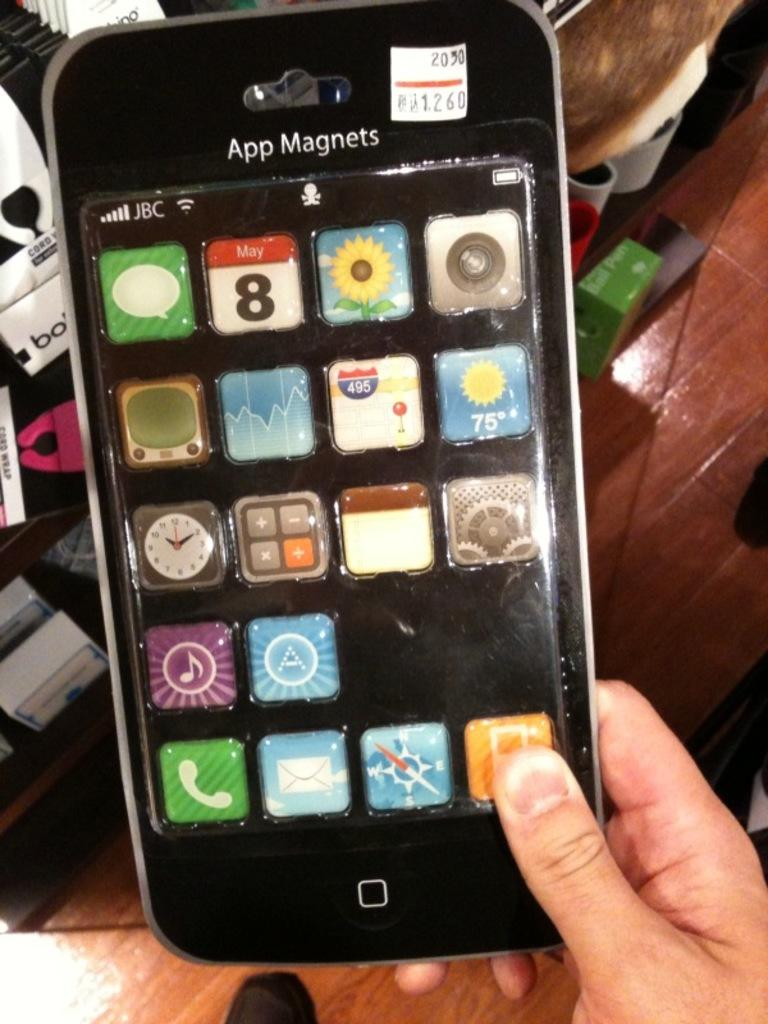<image>
Render a clear and concise summary of the photo. A person holds a black phone with the word App Magnets at the top. 